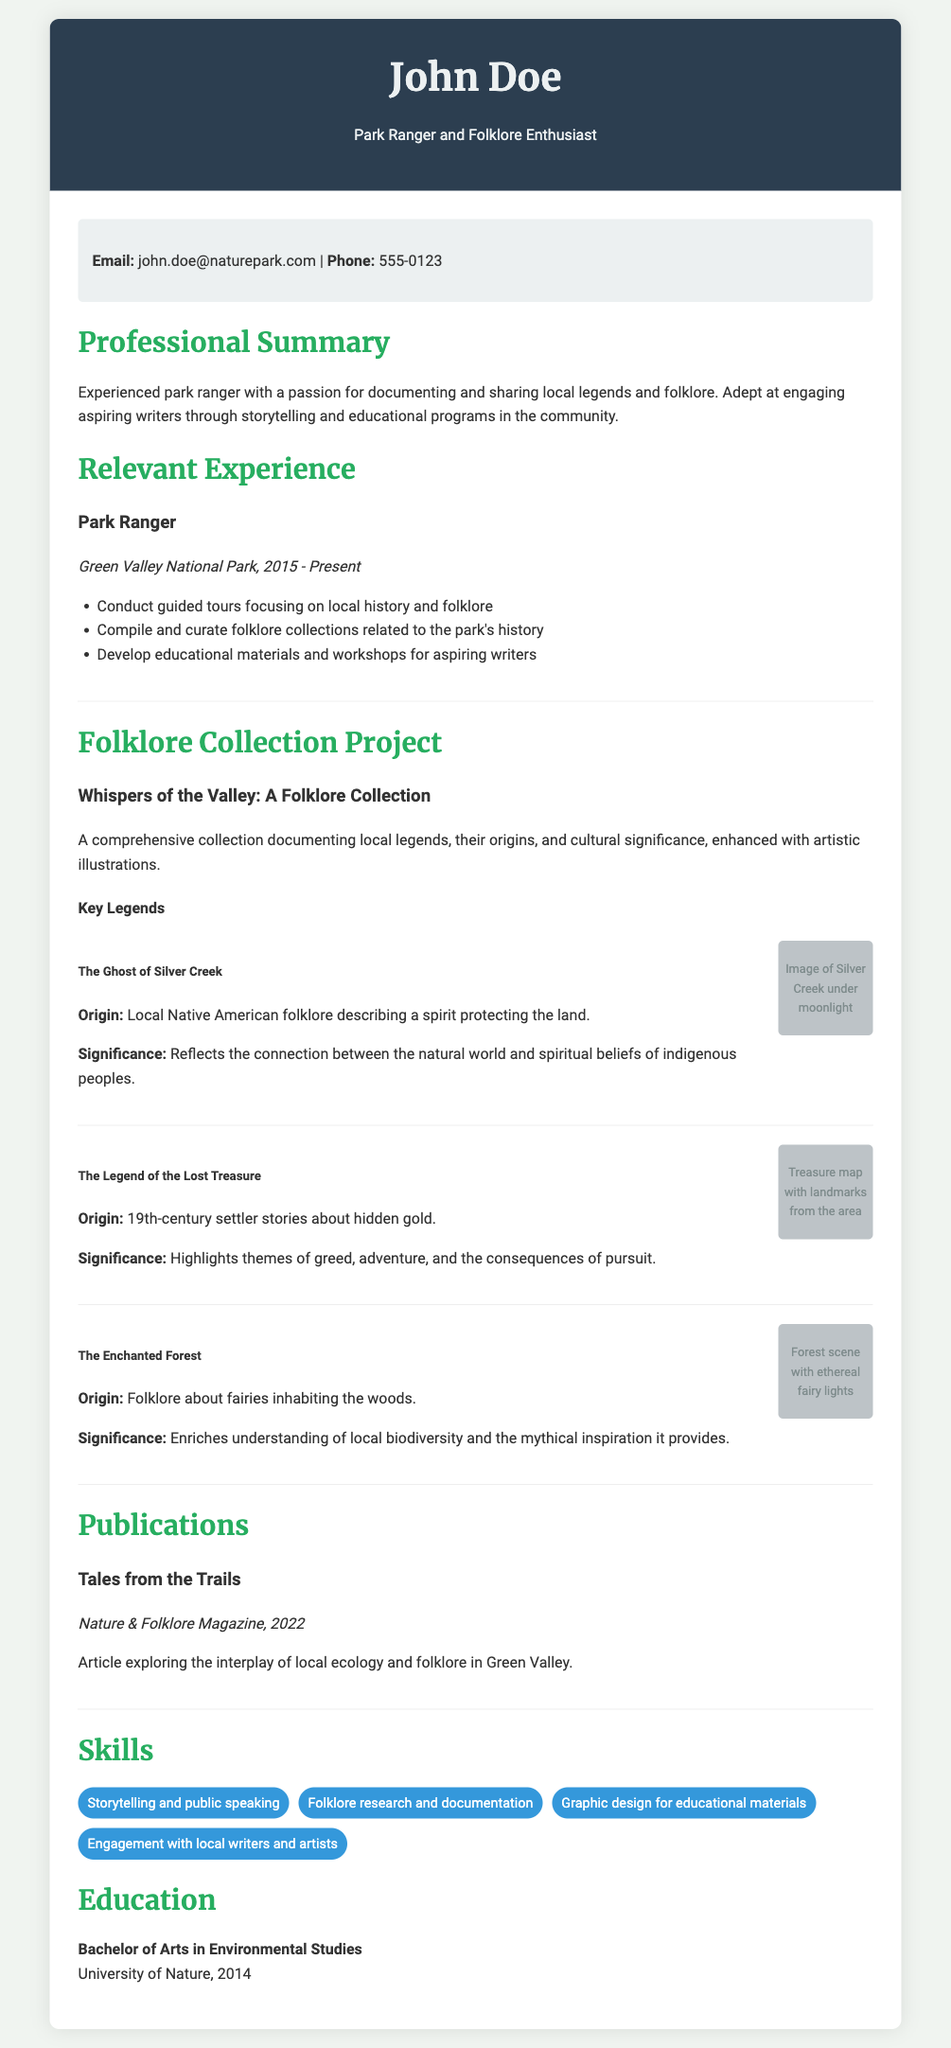What is the name of the park ranger? The document identifies the person as John Doe.
Answer: John Doe What is the email address provided? The email address listed in the contact information is john.doe@naturepark.com.
Answer: john.doe@naturepark.com In which year did John Doe start working as a park ranger? The document states that John Doe has been a park ranger since 2015.
Answer: 2015 What is the title of the folklore collection project? The title mentioned for the folklore collection project is "Whispers of the Valley: A Folklore Collection."
Answer: Whispers of the Valley: A Folklore Collection Which local legend reflects the connection between the natural world and spiritual beliefs? The legend that reflects this connection is "The Ghost of Silver Creek."
Answer: The Ghost of Silver Creek What is the publication title written by John Doe? The title of the publication mentioned is "Tales from the Trails."
Answer: Tales from the Trails How many key legends are highlighted in the document? The document lists three key legends in the folklore collection.
Answer: Three What type of degree does John Doe hold? The document indicates that John Doe has a Bachelor of Arts in Environmental Studies.
Answer: Bachelor of Arts in Environmental Studies What is one of the skills listed in the document? A skill listed is "Storytelling and public speaking."
Answer: Storytelling and public speaking 